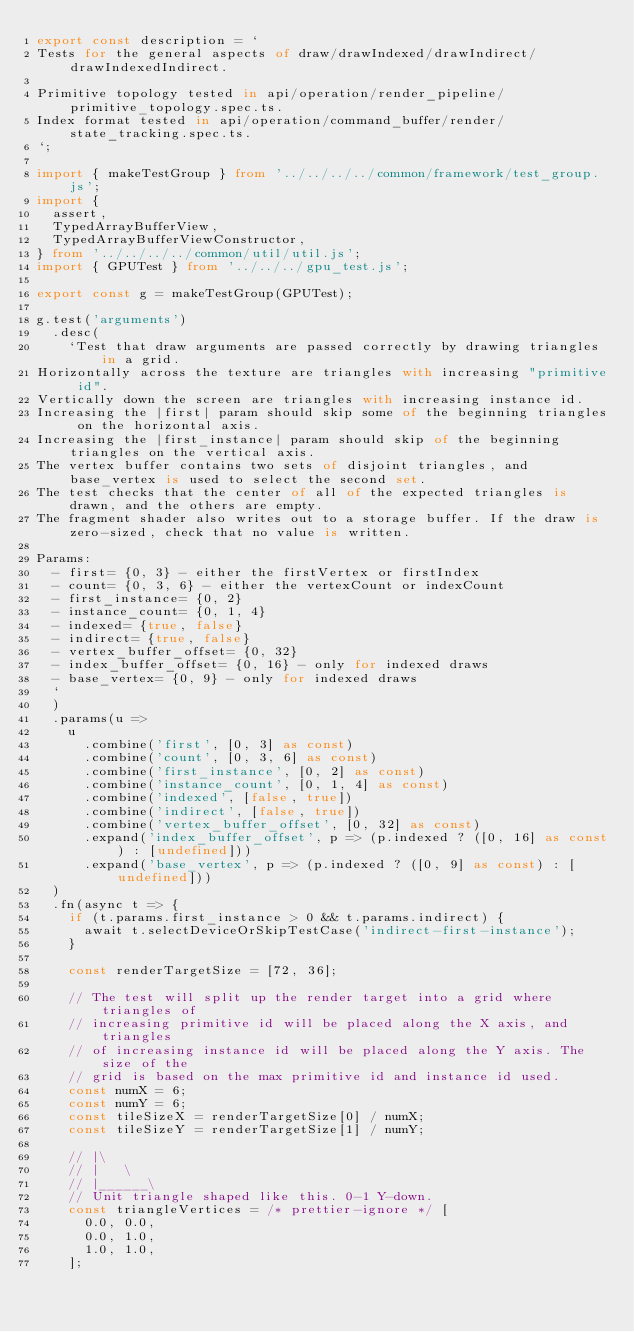Convert code to text. <code><loc_0><loc_0><loc_500><loc_500><_TypeScript_>export const description = `
Tests for the general aspects of draw/drawIndexed/drawIndirect/drawIndexedIndirect.

Primitive topology tested in api/operation/render_pipeline/primitive_topology.spec.ts.
Index format tested in api/operation/command_buffer/render/state_tracking.spec.ts.
`;

import { makeTestGroup } from '../../../../common/framework/test_group.js';
import {
  assert,
  TypedArrayBufferView,
  TypedArrayBufferViewConstructor,
} from '../../../../common/util/util.js';
import { GPUTest } from '../../../gpu_test.js';

export const g = makeTestGroup(GPUTest);

g.test('arguments')
  .desc(
    `Test that draw arguments are passed correctly by drawing triangles in a grid.
Horizontally across the texture are triangles with increasing "primitive id".
Vertically down the screen are triangles with increasing instance id.
Increasing the |first| param should skip some of the beginning triangles on the horizontal axis.
Increasing the |first_instance| param should skip of the beginning triangles on the vertical axis.
The vertex buffer contains two sets of disjoint triangles, and base_vertex is used to select the second set.
The test checks that the center of all of the expected triangles is drawn, and the others are empty.
The fragment shader also writes out to a storage buffer. If the draw is zero-sized, check that no value is written.

Params:
  - first= {0, 3} - either the firstVertex or firstIndex
  - count= {0, 3, 6} - either the vertexCount or indexCount
  - first_instance= {0, 2}
  - instance_count= {0, 1, 4}
  - indexed= {true, false}
  - indirect= {true, false}
  - vertex_buffer_offset= {0, 32}
  - index_buffer_offset= {0, 16} - only for indexed draws
  - base_vertex= {0, 9} - only for indexed draws
  `
  )
  .params(u =>
    u
      .combine('first', [0, 3] as const)
      .combine('count', [0, 3, 6] as const)
      .combine('first_instance', [0, 2] as const)
      .combine('instance_count', [0, 1, 4] as const)
      .combine('indexed', [false, true])
      .combine('indirect', [false, true])
      .combine('vertex_buffer_offset', [0, 32] as const)
      .expand('index_buffer_offset', p => (p.indexed ? ([0, 16] as const) : [undefined]))
      .expand('base_vertex', p => (p.indexed ? ([0, 9] as const) : [undefined]))
  )
  .fn(async t => {
    if (t.params.first_instance > 0 && t.params.indirect) {
      await t.selectDeviceOrSkipTestCase('indirect-first-instance');
    }

    const renderTargetSize = [72, 36];

    // The test will split up the render target into a grid where triangles of
    // increasing primitive id will be placed along the X axis, and triangles
    // of increasing instance id will be placed along the Y axis. The size of the
    // grid is based on the max primitive id and instance id used.
    const numX = 6;
    const numY = 6;
    const tileSizeX = renderTargetSize[0] / numX;
    const tileSizeY = renderTargetSize[1] / numY;

    // |\
    // |   \
    // |______\
    // Unit triangle shaped like this. 0-1 Y-down.
    const triangleVertices = /* prettier-ignore */ [
      0.0, 0.0,
      0.0, 1.0,
      1.0, 1.0,
    ];
</code> 